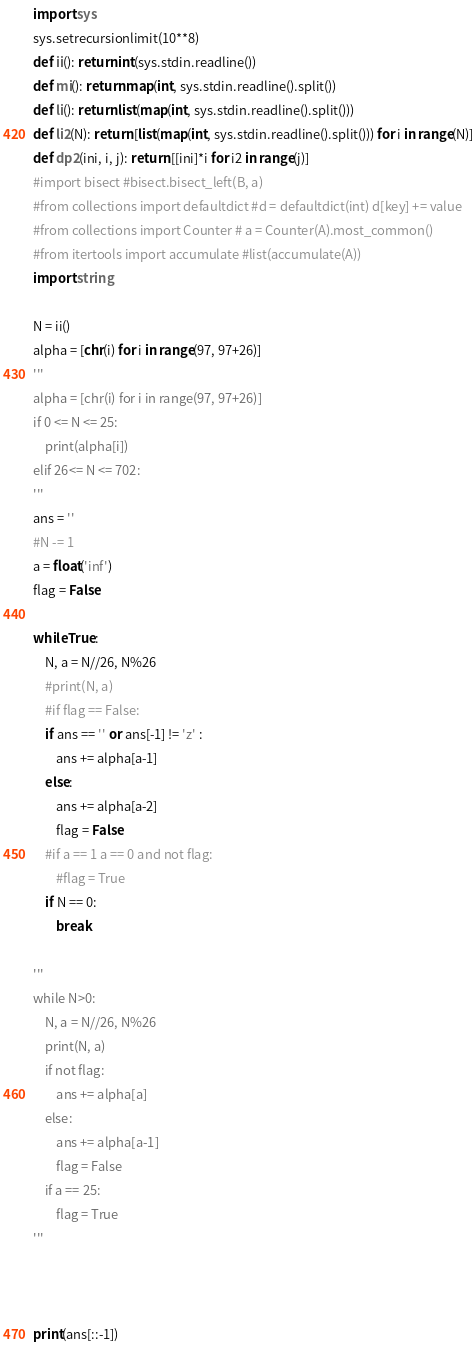<code> <loc_0><loc_0><loc_500><loc_500><_Python_>import sys
sys.setrecursionlimit(10**8)
def ii(): return int(sys.stdin.readline())
def mi(): return map(int, sys.stdin.readline().split())
def li(): return list(map(int, sys.stdin.readline().split()))
def li2(N): return [list(map(int, sys.stdin.readline().split())) for i in range(N)]
def dp2(ini, i, j): return [[ini]*i for i2 in range(j)]
#import bisect #bisect.bisect_left(B, a)
#from collections import defaultdict #d = defaultdict(int) d[key] += value
#from collections import Counter # a = Counter(A).most_common()
#from itertools import accumulate #list(accumulate(A))
import string

N = ii()
alpha = [chr(i) for i in range(97, 97+26)]
'''
alpha = [chr(i) for i in range(97, 97+26)]
if 0 <= N <= 25:
    print(alpha[i])
elif 26<= N <= 702:
'''
ans = ''
#N -= 1
a = float('inf')
flag = False

while True:
    N, a = N//26, N%26
    #print(N, a)
    #if flag == False:
    if ans == '' or ans[-1] != 'z' :
        ans += alpha[a-1]
    else:
        ans += alpha[a-2]
        flag = False
    #if a == 1 a == 0 and not flag:
        #flag = True
    if N == 0:
        break

'''
while N>0:
    N, a = N//26, N%26
    print(N, a)
    if not flag:
        ans += alpha[a]
    else:
        ans += alpha[a-1]
        flag = False
    if a == 25:
        flag = True
'''



print(ans[::-1])</code> 